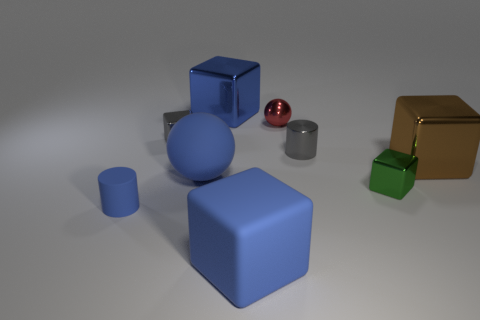Subtract all brown blocks. How many blocks are left? 4 Subtract all rubber blocks. How many blocks are left? 4 Subtract all brown cubes. Subtract all gray cylinders. How many cubes are left? 4 Add 1 red things. How many objects exist? 10 Subtract all balls. How many objects are left? 7 Add 7 small blue metal things. How many small blue metal things exist? 7 Subtract 0 red cylinders. How many objects are left? 9 Subtract all big blue rubber things. Subtract all large brown matte balls. How many objects are left? 7 Add 8 small red metal balls. How many small red metal balls are left? 9 